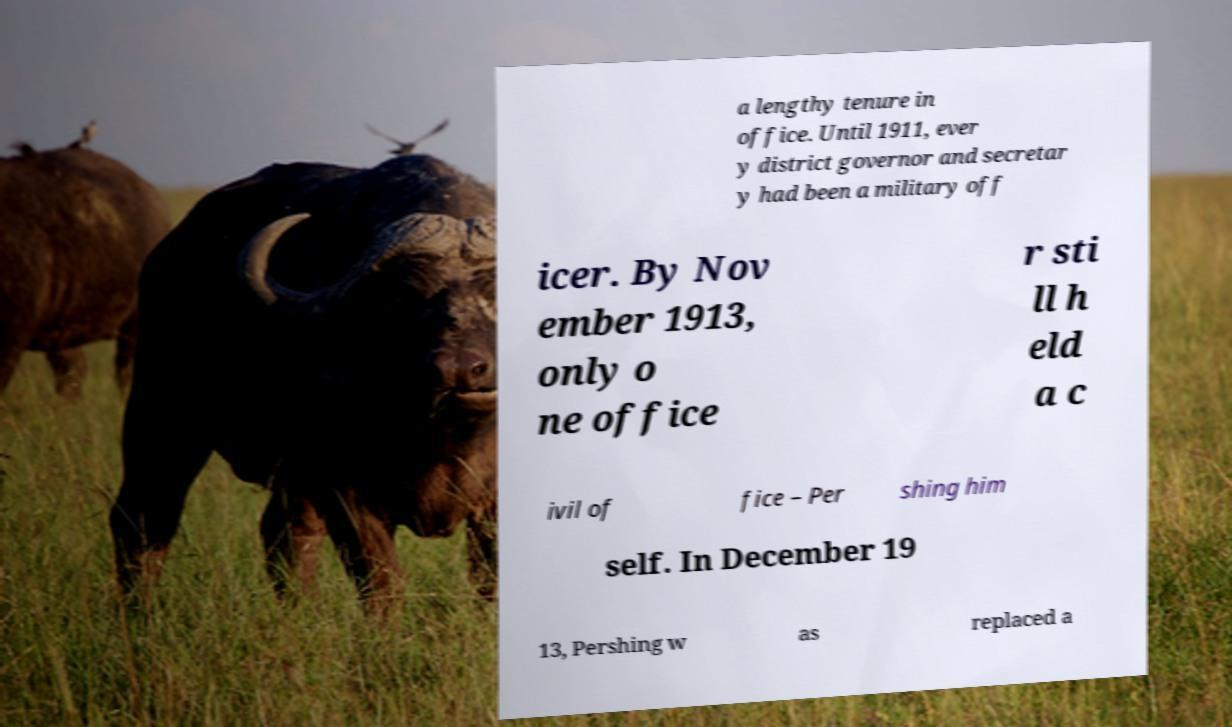For documentation purposes, I need the text within this image transcribed. Could you provide that? a lengthy tenure in office. Until 1911, ever y district governor and secretar y had been a military off icer. By Nov ember 1913, only o ne office r sti ll h eld a c ivil of fice – Per shing him self. In December 19 13, Pershing w as replaced a 